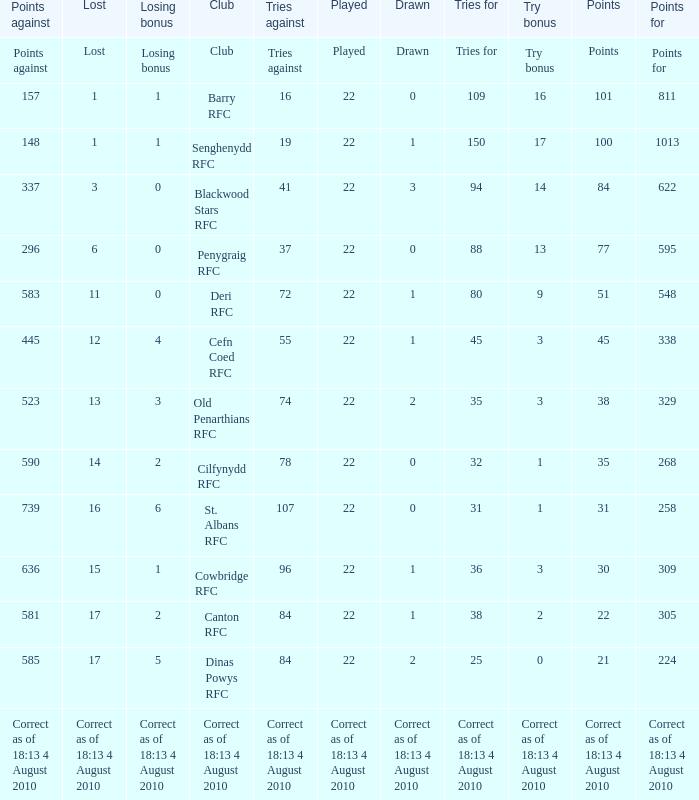What is the total number of games played when there are 84 attempts against and 2 draws? 22.0. 